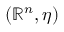<formula> <loc_0><loc_0><loc_500><loc_500>( \mathbb { R } ^ { n } , \eta )</formula> 